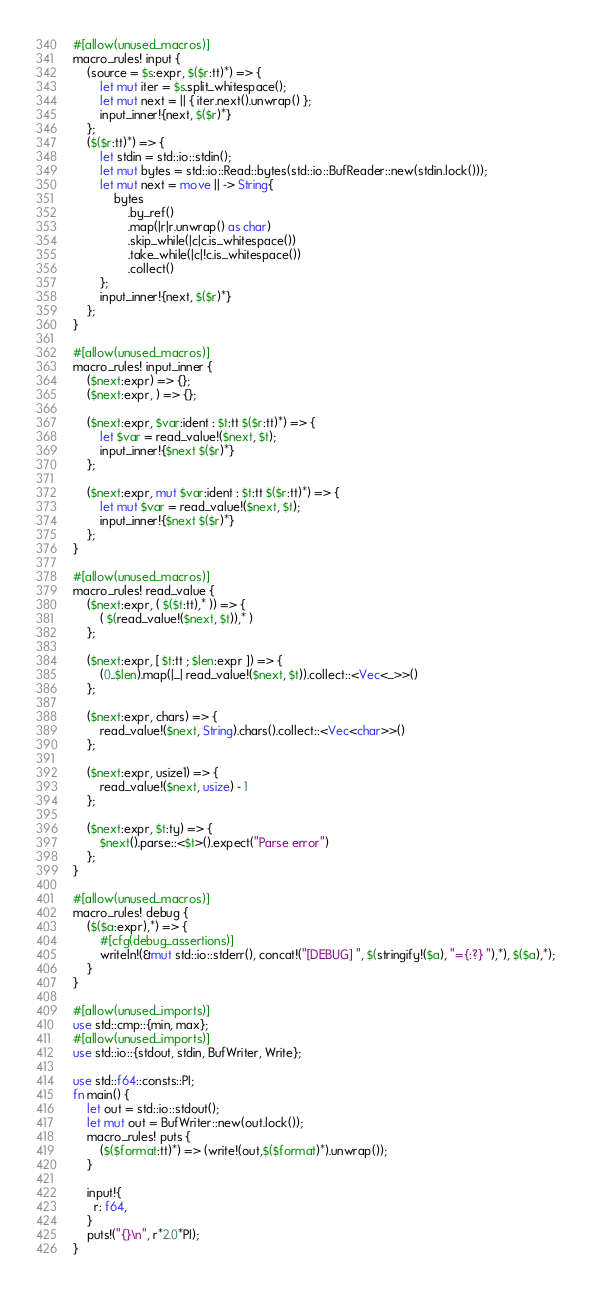Convert code to text. <code><loc_0><loc_0><loc_500><loc_500><_Rust_>#[allow(unused_macros)]
macro_rules! input {
    (source = $s:expr, $($r:tt)*) => {
        let mut iter = $s.split_whitespace();
        let mut next = || { iter.next().unwrap() };
        input_inner!{next, $($r)*}
    };
    ($($r:tt)*) => {
        let stdin = std::io::stdin();
        let mut bytes = std::io::Read::bytes(std::io::BufReader::new(stdin.lock()));
        let mut next = move || -> String{
            bytes
                .by_ref()
                .map(|r|r.unwrap() as char)
                .skip_while(|c|c.is_whitespace())
                .take_while(|c|!c.is_whitespace())
                .collect()
        };
        input_inner!{next, $($r)*}
    };
}

#[allow(unused_macros)]
macro_rules! input_inner {
    ($next:expr) => {};
    ($next:expr, ) => {};

    ($next:expr, $var:ident : $t:tt $($r:tt)*) => {
        let $var = read_value!($next, $t);
        input_inner!{$next $($r)*}
    };

    ($next:expr, mut $var:ident : $t:tt $($r:tt)*) => {
        let mut $var = read_value!($next, $t);
        input_inner!{$next $($r)*}
    };
}

#[allow(unused_macros)]
macro_rules! read_value {
    ($next:expr, ( $($t:tt),* )) => {
        ( $(read_value!($next, $t)),* )
    };

    ($next:expr, [ $t:tt ; $len:expr ]) => {
        (0..$len).map(|_| read_value!($next, $t)).collect::<Vec<_>>()
    };

    ($next:expr, chars) => {
        read_value!($next, String).chars().collect::<Vec<char>>()
    };

    ($next:expr, usize1) => {
        read_value!($next, usize) - 1
    };

    ($next:expr, $t:ty) => {
        $next().parse::<$t>().expect("Parse error")
    };
}

#[allow(unused_macros)]
macro_rules! debug {
    ($($a:expr),*) => {
        #[cfg(debug_assertions)]
        writeln!(&mut std::io::stderr(), concat!("[DEBUG] ", $(stringify!($a), "={:?} "),*), $($a),*);
    }
}

#[allow(unused_imports)]
use std::cmp::{min, max};
#[allow(unused_imports)]
use std::io::{stdout, stdin, BufWriter, Write};

use std::f64::consts::PI;
fn main() {
    let out = std::io::stdout();
    let mut out = BufWriter::new(out.lock());
    macro_rules! puts {
        ($($format:tt)*) => (write!(out,$($format)*).unwrap());
    }

    input!{
      r: f64,
    }
    puts!("{}\n", r*2.0*PI);
}
</code> 